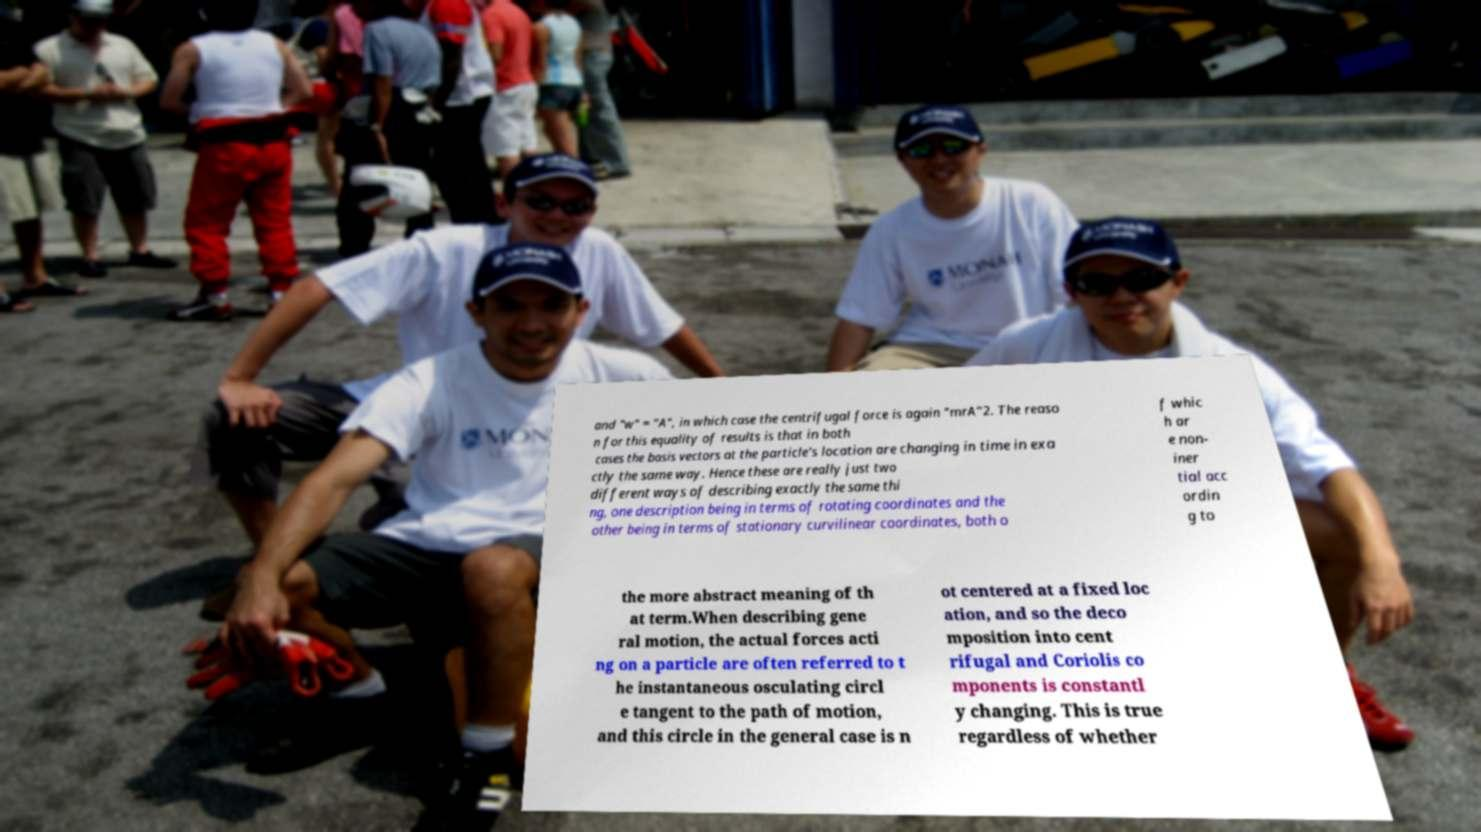Can you read and provide the text displayed in the image?This photo seems to have some interesting text. Can you extract and type it out for me? and "w" = "A", in which case the centrifugal force is again "mrA"2. The reaso n for this equality of results is that in both cases the basis vectors at the particle's location are changing in time in exa ctly the same way. Hence these are really just two different ways of describing exactly the same thi ng, one description being in terms of rotating coordinates and the other being in terms of stationary curvilinear coordinates, both o f whic h ar e non- iner tial acc ordin g to the more abstract meaning of th at term.When describing gene ral motion, the actual forces acti ng on a particle are often referred to t he instantaneous osculating circl e tangent to the path of motion, and this circle in the general case is n ot centered at a fixed loc ation, and so the deco mposition into cent rifugal and Coriolis co mponents is constantl y changing. This is true regardless of whether 